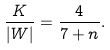<formula> <loc_0><loc_0><loc_500><loc_500>\frac { K } { | W | } = \frac { 4 } { 7 + n } .</formula> 